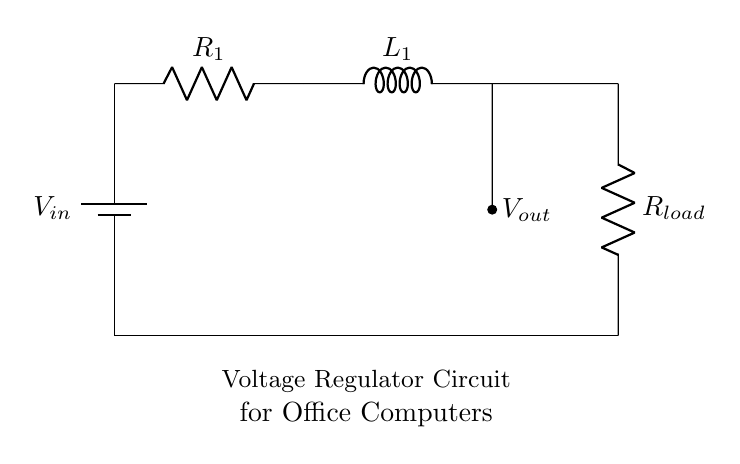What is the input voltage of this circuit? The input voltage is indicated as V_in at the battery connection in the diagram.
Answer: V_in What is the purpose of the inductor in this circuit? The inductor is used to smooth out voltage fluctuations and improve stability in the power supply to the load.
Answer: Stability What is the value of the load resistor? The load resistor is labeled as R_load in the circuit diagram, indicating it is part of the load. The exact value is not specified in the diagram.
Answer: R_load How many resistors are in this circuit? The circuit contains two resistors: R_1 and R_load.
Answer: 2 What is the output voltage connection point? The output voltage, represented as V_out, is connected at the point between inductor L_1 and the load resistor R_load.
Answer: Between L_1 and R_load What happens to the current when the load increases? When the load increases, the current through the circuit increases, which may lead to a drop in voltage if the circuit isn't designed to handle the additional current demand.
Answer: Increases What type of filtering action does the inductor provide? The inductor provides low-pass filtering action, allowing DC components to pass while blocking high-frequency AC noise.
Answer: Low-pass filtering 